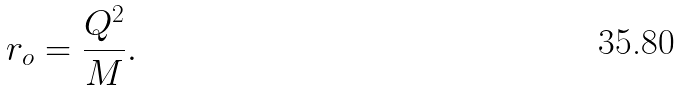<formula> <loc_0><loc_0><loc_500><loc_500>r _ { o } = \frac { Q ^ { 2 } } M .</formula> 